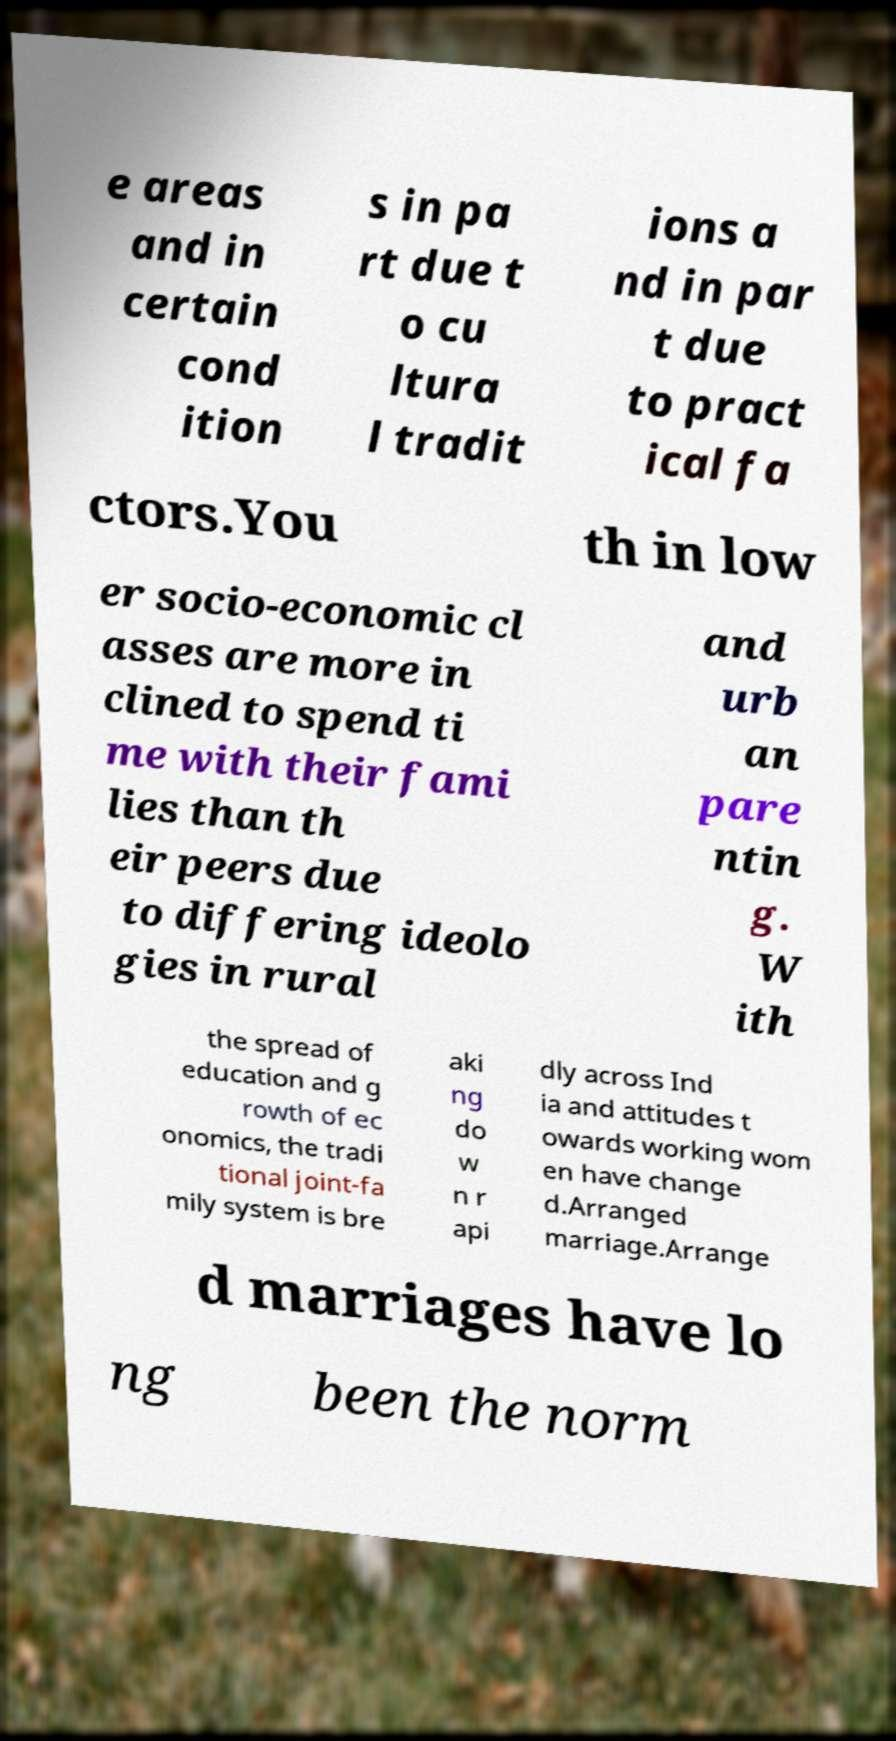Can you read and provide the text displayed in the image?This photo seems to have some interesting text. Can you extract and type it out for me? e areas and in certain cond ition s in pa rt due t o cu ltura l tradit ions a nd in par t due to pract ical fa ctors.You th in low er socio-economic cl asses are more in clined to spend ti me with their fami lies than th eir peers due to differing ideolo gies in rural and urb an pare ntin g. W ith the spread of education and g rowth of ec onomics, the tradi tional joint-fa mily system is bre aki ng do w n r api dly across Ind ia and attitudes t owards working wom en have change d.Arranged marriage.Arrange d marriages have lo ng been the norm 